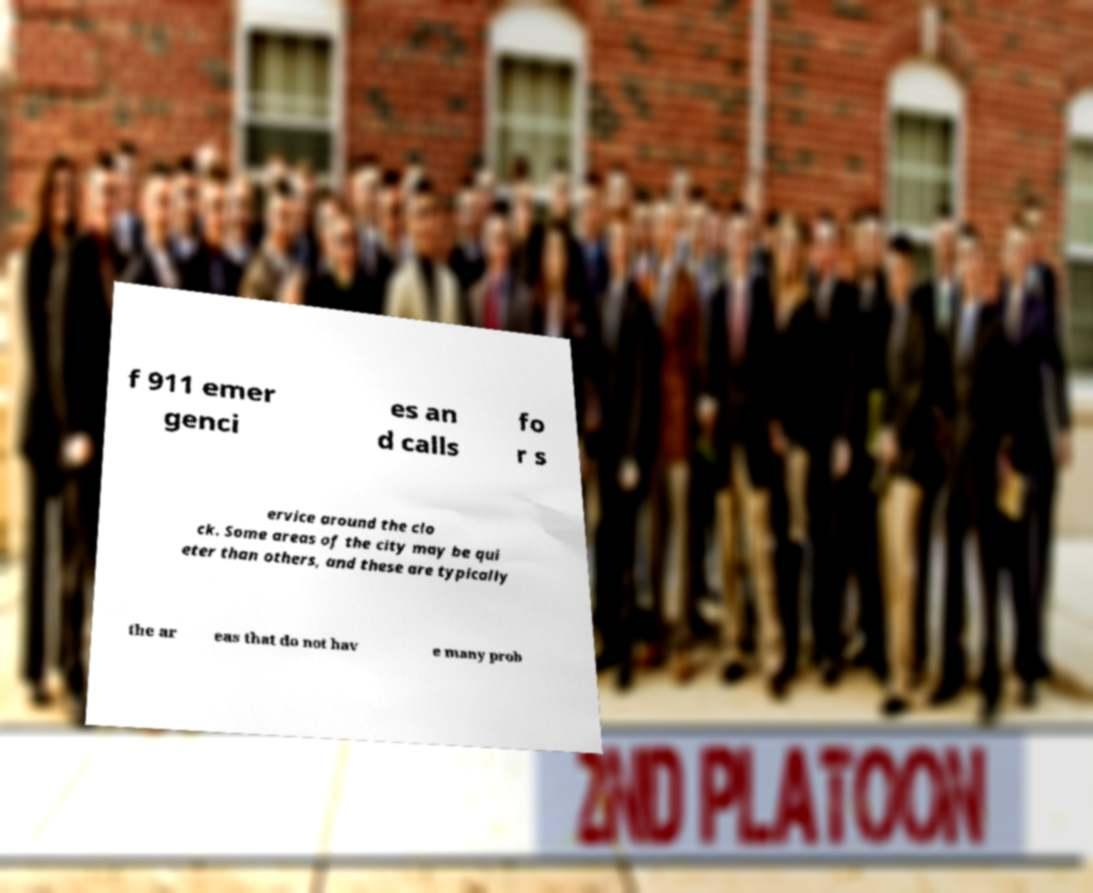Can you read and provide the text displayed in the image?This photo seems to have some interesting text. Can you extract and type it out for me? f 911 emer genci es an d calls fo r s ervice around the clo ck. Some areas of the city may be qui eter than others, and these are typically the ar eas that do not hav e many prob 